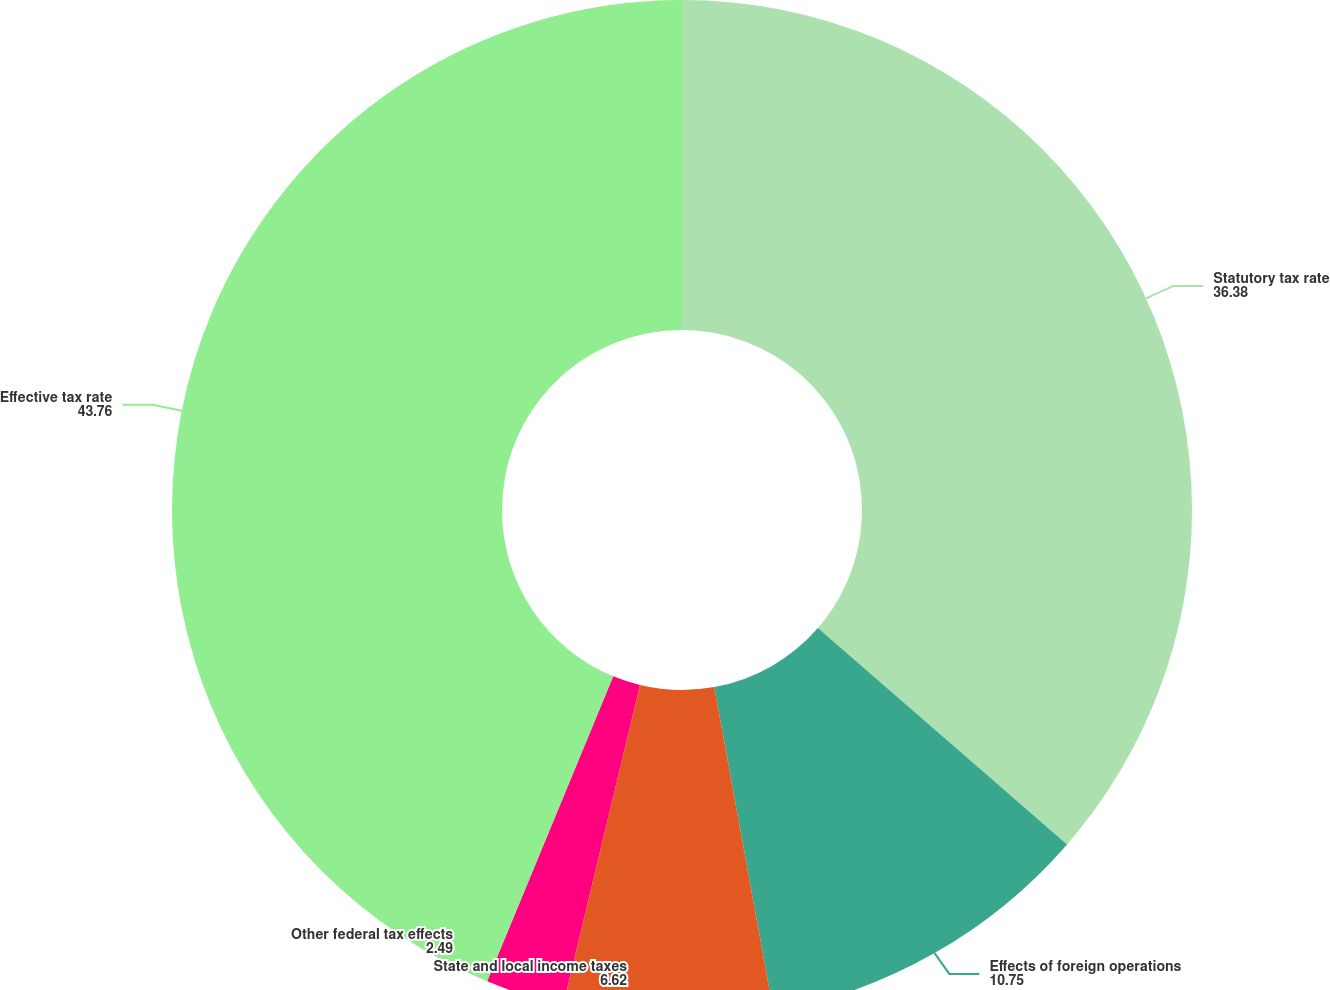Convert chart. <chart><loc_0><loc_0><loc_500><loc_500><pie_chart><fcel>Statutory tax rate<fcel>Effects of foreign operations<fcel>State and local income taxes<fcel>Other federal tax effects<fcel>Effective tax rate<nl><fcel>36.38%<fcel>10.75%<fcel>6.62%<fcel>2.49%<fcel>43.76%<nl></chart> 